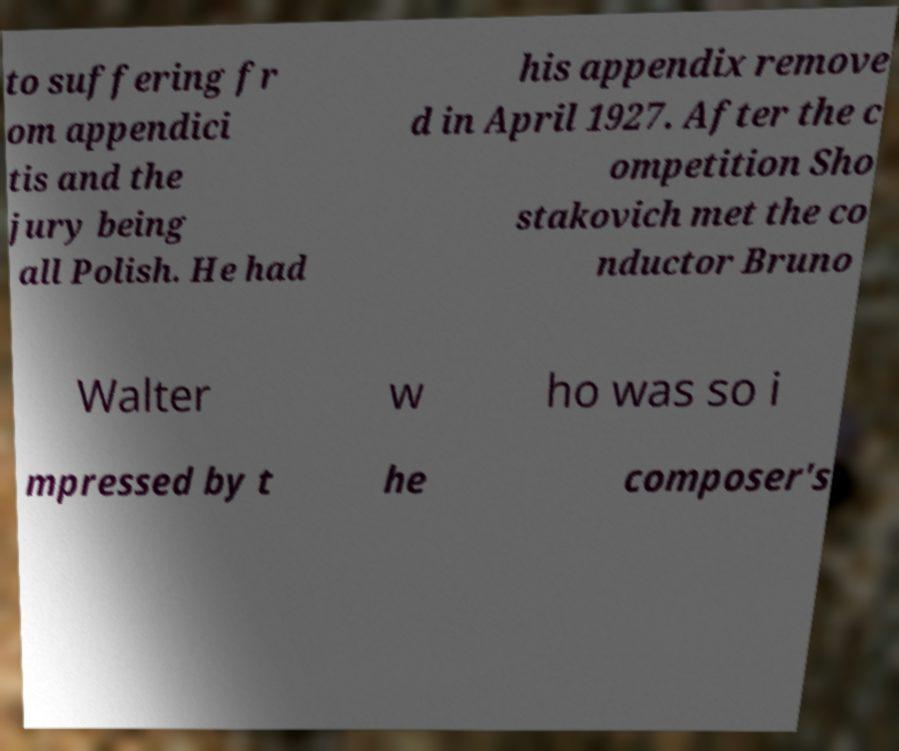Could you extract and type out the text from this image? to suffering fr om appendici tis and the jury being all Polish. He had his appendix remove d in April 1927. After the c ompetition Sho stakovich met the co nductor Bruno Walter w ho was so i mpressed by t he composer's 